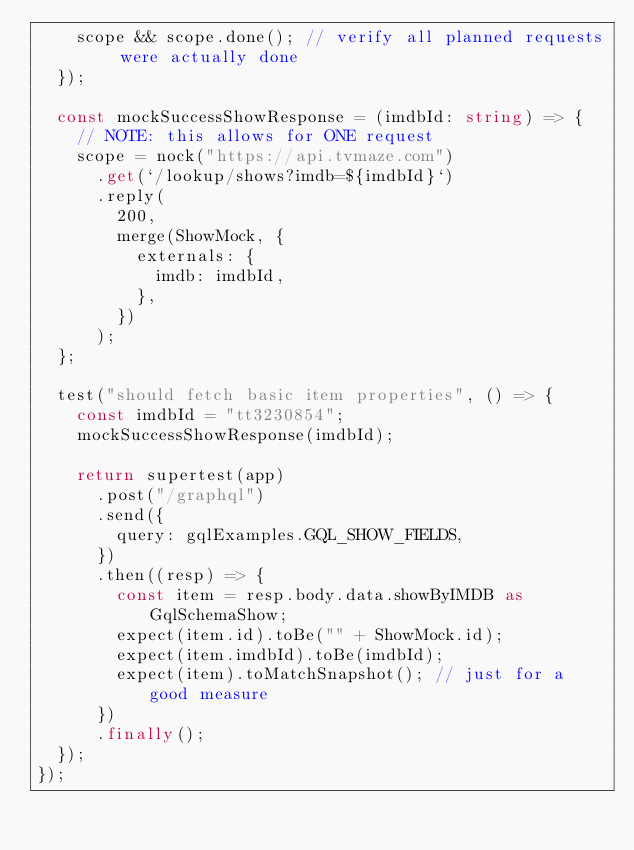Convert code to text. <code><loc_0><loc_0><loc_500><loc_500><_TypeScript_>    scope && scope.done(); // verify all planned requests were actually done
  });

  const mockSuccessShowResponse = (imdbId: string) => {
    // NOTE: this allows for ONE request
    scope = nock("https://api.tvmaze.com")
      .get(`/lookup/shows?imdb=${imdbId}`)
      .reply(
        200,
        merge(ShowMock, {
          externals: {
            imdb: imdbId,
          },
        })
      );
  };

  test("should fetch basic item properties", () => {
    const imdbId = "tt3230854";
    mockSuccessShowResponse(imdbId);

    return supertest(app)
      .post("/graphql")
      .send({
        query: gqlExamples.GQL_SHOW_FIELDS,
      })
      .then((resp) => {
        const item = resp.body.data.showByIMDB as GqlSchemaShow;
        expect(item.id).toBe("" + ShowMock.id);
        expect(item.imdbId).toBe(imdbId);
        expect(item).toMatchSnapshot(); // just for a good measure
      })
      .finally();
  });
});
</code> 